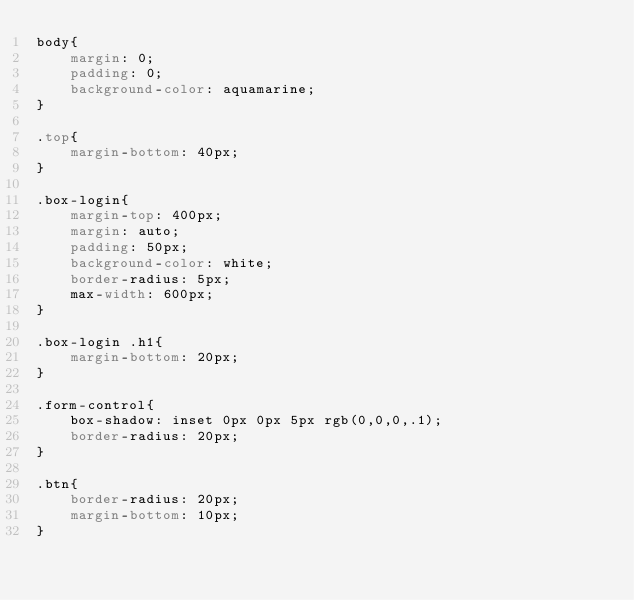<code> <loc_0><loc_0><loc_500><loc_500><_CSS_>body{
    margin: 0;
    padding: 0;
    background-color: aquamarine;
}

.top{
    margin-bottom: 40px;
}

.box-login{
    margin-top: 400px;
    margin: auto;
    padding: 50px;
    background-color: white;
    border-radius: 5px;
    max-width: 600px;
}

.box-login .h1{
    margin-bottom: 20px;
}

.form-control{
    box-shadow: inset 0px 0px 5px rgb(0,0,0,.1);
    border-radius: 20px;
}

.btn{
    border-radius: 20px;
    margin-bottom: 10px;
}</code> 